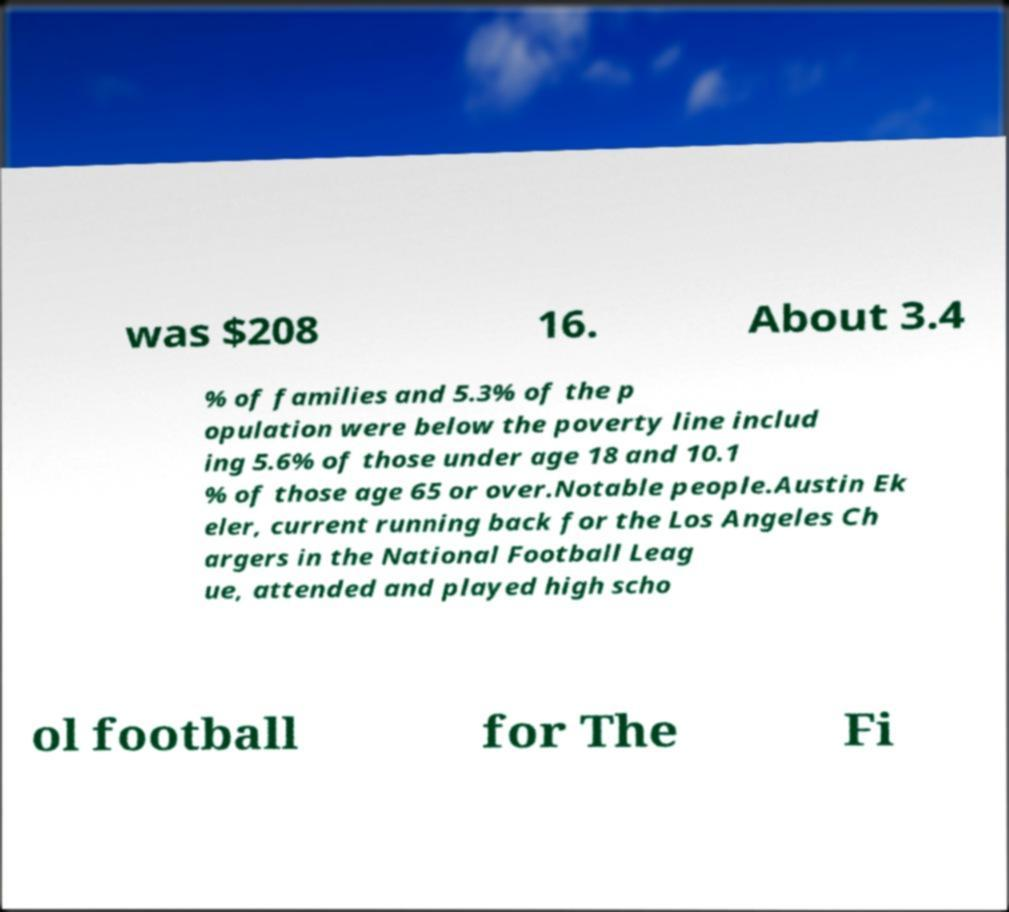What messages or text are displayed in this image? I need them in a readable, typed format. was $208 16. About 3.4 % of families and 5.3% of the p opulation were below the poverty line includ ing 5.6% of those under age 18 and 10.1 % of those age 65 or over.Notable people.Austin Ek eler, current running back for the Los Angeles Ch argers in the National Football Leag ue, attended and played high scho ol football for The Fi 